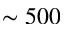<formula> <loc_0><loc_0><loc_500><loc_500>\sim 5 0 0</formula> 